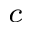<formula> <loc_0><loc_0><loc_500><loc_500>^ { c }</formula> 